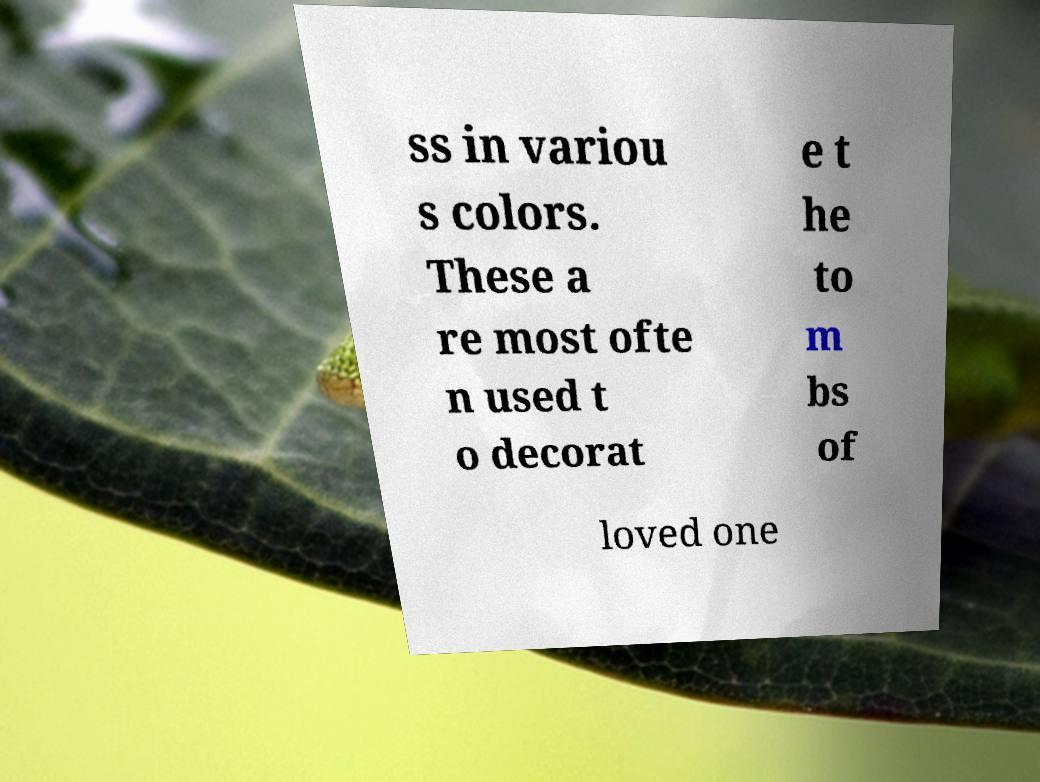Please read and relay the text visible in this image. What does it say? ss in variou s colors. These a re most ofte n used t o decorat e t he to m bs of loved one 